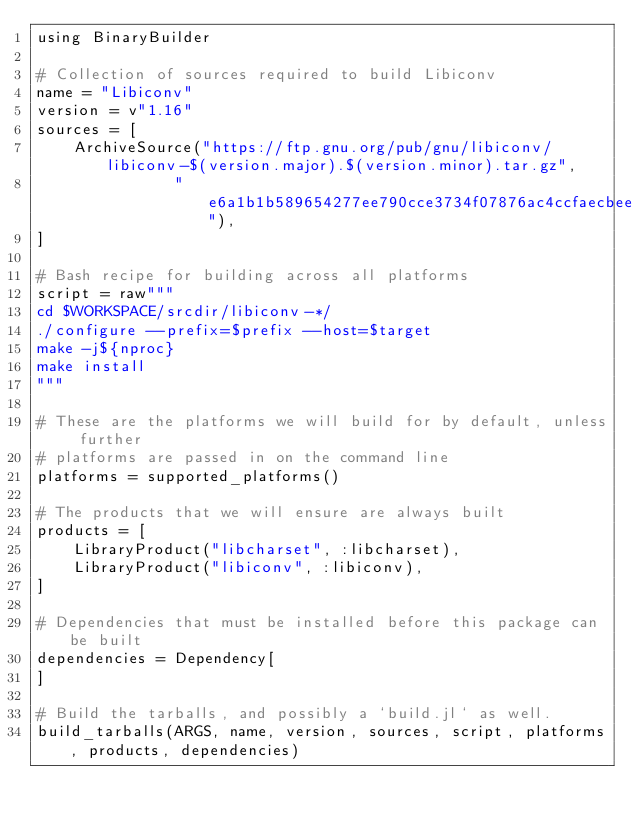<code> <loc_0><loc_0><loc_500><loc_500><_Julia_>using BinaryBuilder

# Collection of sources required to build Libiconv
name = "Libiconv"
version = v"1.16"
sources = [
    ArchiveSource("https://ftp.gnu.org/pub/gnu/libiconv/libiconv-$(version.major).$(version.minor).tar.gz",
               "e6a1b1b589654277ee790cce3734f07876ac4ccfaecbee8afa0b649cf529cc04"),
]

# Bash recipe for building across all platforms
script = raw"""
cd $WORKSPACE/srcdir/libiconv-*/
./configure --prefix=$prefix --host=$target
make -j${nproc}
make install
"""

# These are the platforms we will build for by default, unless further
# platforms are passed in on the command line
platforms = supported_platforms()

# The products that we will ensure are always built
products = [
    LibraryProduct("libcharset", :libcharset),
    LibraryProduct("libiconv", :libiconv),
]

# Dependencies that must be installed before this package can be built
dependencies = Dependency[
]

# Build the tarballs, and possibly a `build.jl` as well.
build_tarballs(ARGS, name, version, sources, script, platforms, products, dependencies)

</code> 